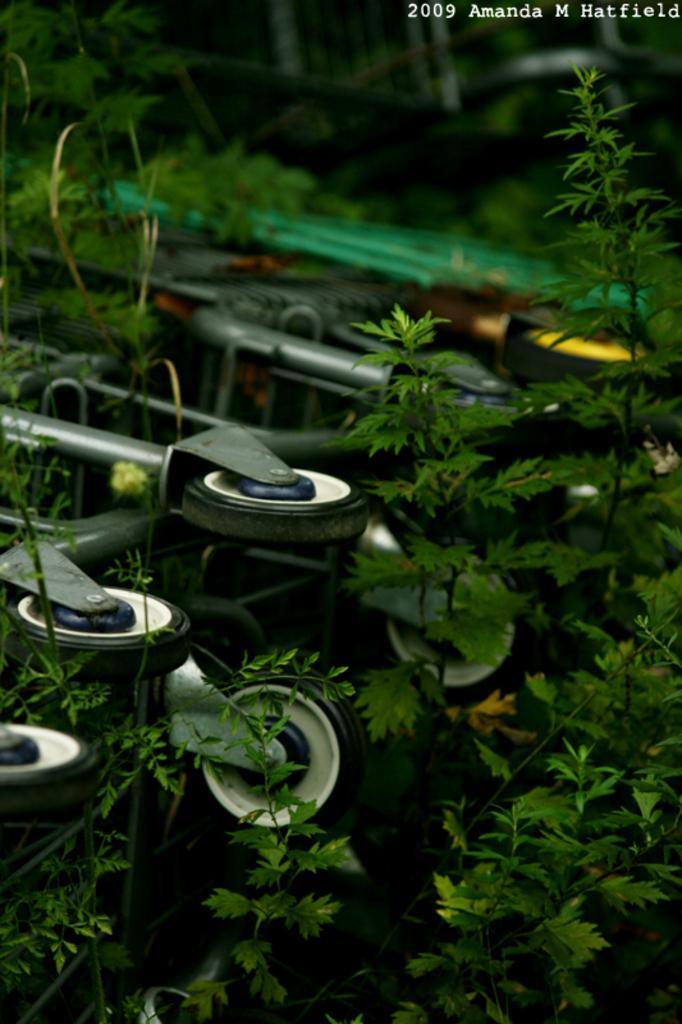Could you give a brief overview of what you see in this image? In this image we can see wheels to the stand and plants here. The image is slightly blurred here. Here we can see some edited text. 